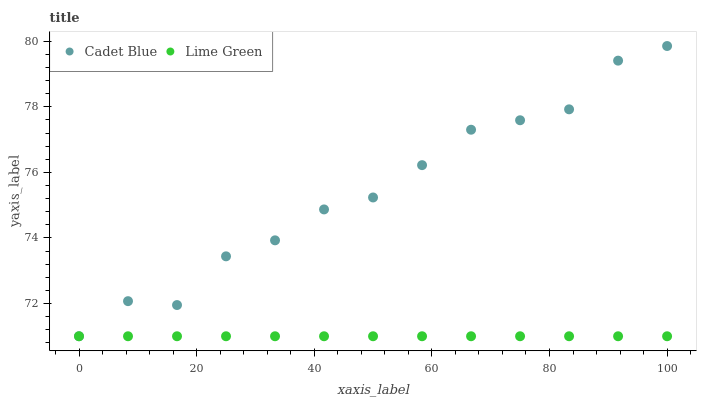Does Lime Green have the minimum area under the curve?
Answer yes or no. Yes. Does Cadet Blue have the maximum area under the curve?
Answer yes or no. Yes. Does Lime Green have the maximum area under the curve?
Answer yes or no. No. Is Lime Green the smoothest?
Answer yes or no. Yes. Is Cadet Blue the roughest?
Answer yes or no. Yes. Is Lime Green the roughest?
Answer yes or no. No. Does Cadet Blue have the lowest value?
Answer yes or no. Yes. Does Cadet Blue have the highest value?
Answer yes or no. Yes. Does Lime Green have the highest value?
Answer yes or no. No. Does Cadet Blue intersect Lime Green?
Answer yes or no. Yes. Is Cadet Blue less than Lime Green?
Answer yes or no. No. Is Cadet Blue greater than Lime Green?
Answer yes or no. No. 